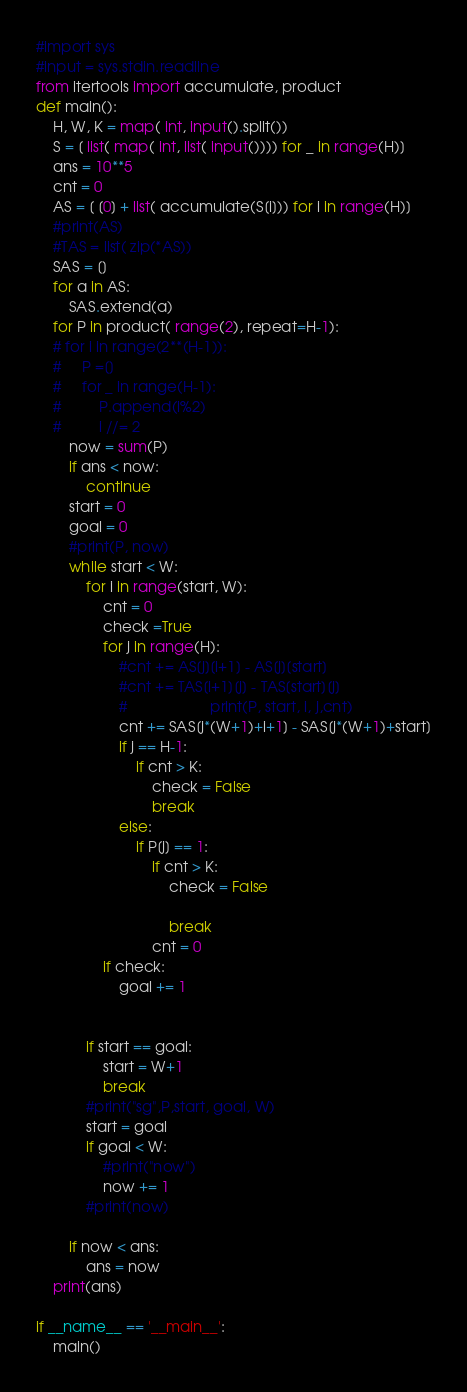Convert code to text. <code><loc_0><loc_0><loc_500><loc_500><_Python_>#import sys
#input = sys.stdin.readline
from itertools import accumulate, product
def main():
    H, W, K = map( int, input().split())
    S = [ list( map( int, list( input()))) for _ in range(H)]
    ans = 10**5
    cnt = 0
    AS = [ [0] + list( accumulate(S[i])) for i in range(H)]
    #print(AS)
    #TAS = list( zip(*AS))
    SAS = []
    for a in AS:
        SAS.extend(a)
    for P in product( range(2), repeat=H-1):
    # for i in range(2**(H-1)):
    #     P =[]
    #     for _ in range(H-1):
    #         P.append(i%2)
    #         i //= 2
        now = sum(P)
        if ans < now:
            continue
        start = 0
        goal = 0
        #print(P, now)
        while start < W:
            for i in range(start, W):
                cnt = 0
                check =True
                for j in range(H):
                    #cnt += AS[j][i+1] - AS[j][start]
                    #cnt += TAS[i+1][j] - TAS[start][j]
                    #                    print(P, start, i, j,cnt)
                    cnt += SAS[j*(W+1)+i+1] - SAS[j*(W+1)+start]
                    if j == H-1:
                        if cnt > K:
                            check = False
                            break
                    else:
                        if P[j] == 1:
                            if cnt > K:
                                check = False
                                
                                break
                            cnt = 0
                if check:
                    goal += 1

                    
            if start == goal:
                start = W+1
                break
            #print("sg",P,start, goal, W)
            start = goal
            if goal < W:
                #print("now")
                now += 1
            #print(now)
        
        if now < ans:
            ans = now
    print(ans)
                
if __name__ == '__main__':
    main()
</code> 